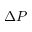<formula> <loc_0><loc_0><loc_500><loc_500>\Delta P</formula> 